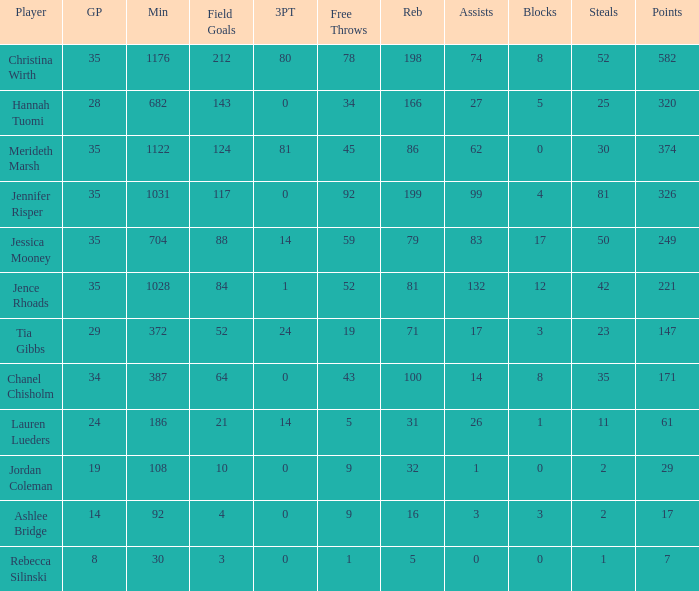For how long did Jordan Coleman play? 108.0. 